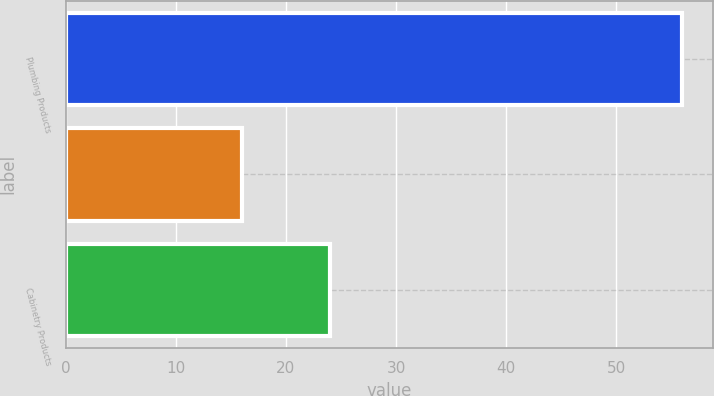Convert chart to OTSL. <chart><loc_0><loc_0><loc_500><loc_500><bar_chart><fcel>Plumbing Products<fcel>Unnamed: 1<fcel>Cabinetry Products<nl><fcel>56<fcel>16<fcel>24<nl></chart> 